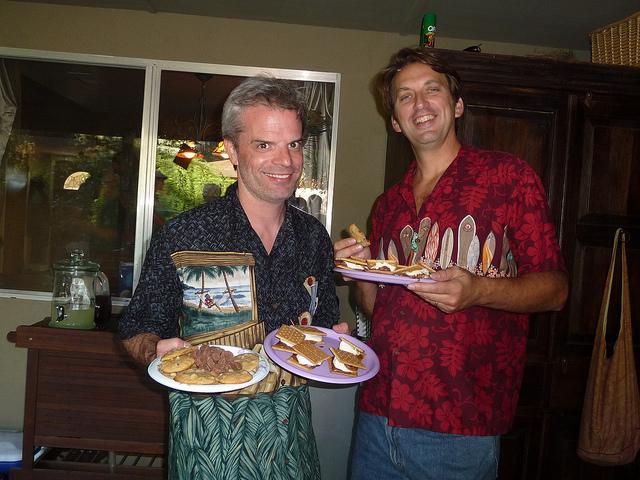Are their shirts patterned or solid?
Be succinct. Patterned. Is the man's cookie mostly eaten?
Answer briefly. Yes. What hangs on the door?
Quick response, please. Bag. 